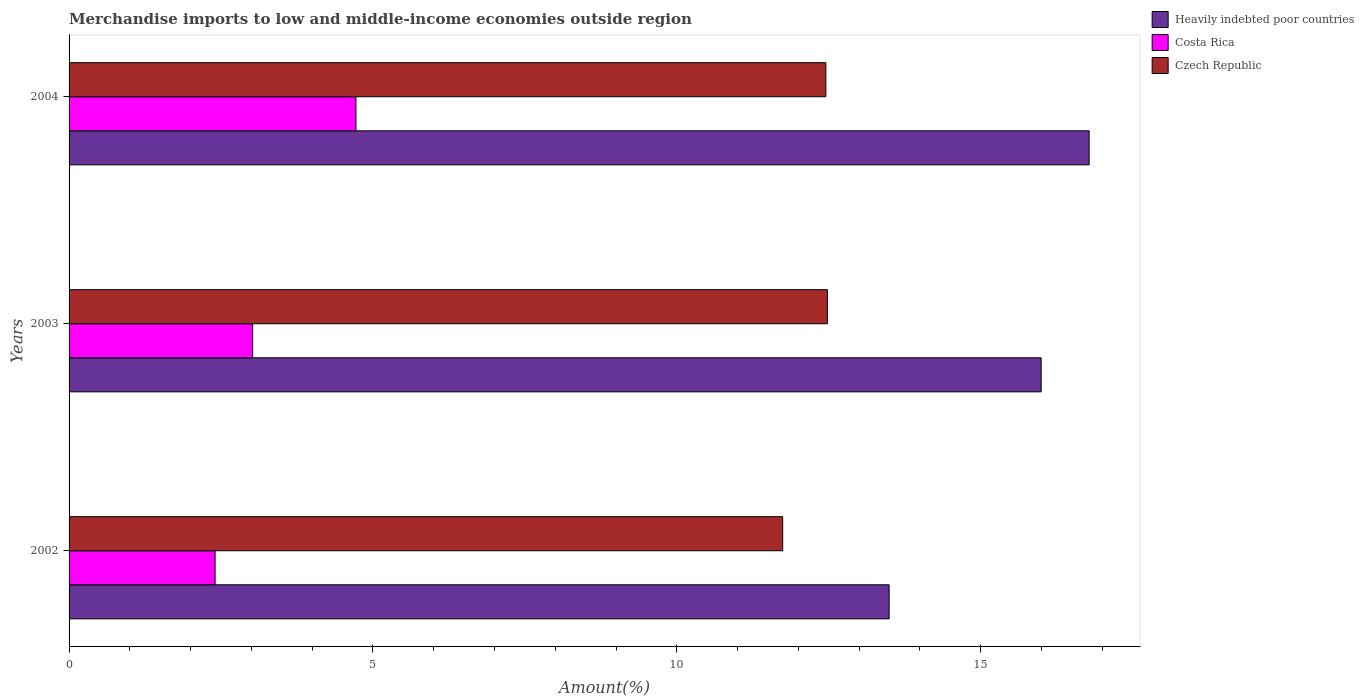In how many cases, is the number of bars for a given year not equal to the number of legend labels?
Keep it short and to the point. 0. What is the percentage of amount earned from merchandise imports in Czech Republic in 2004?
Offer a very short reply. 12.45. Across all years, what is the maximum percentage of amount earned from merchandise imports in Costa Rica?
Make the answer very short. 4.72. Across all years, what is the minimum percentage of amount earned from merchandise imports in Costa Rica?
Provide a succinct answer. 2.4. What is the total percentage of amount earned from merchandise imports in Costa Rica in the graph?
Make the answer very short. 10.14. What is the difference between the percentage of amount earned from merchandise imports in Czech Republic in 2003 and that in 2004?
Provide a short and direct response. 0.03. What is the difference between the percentage of amount earned from merchandise imports in Heavily indebted poor countries in 2004 and the percentage of amount earned from merchandise imports in Costa Rica in 2002?
Offer a terse response. 14.38. What is the average percentage of amount earned from merchandise imports in Heavily indebted poor countries per year?
Offer a very short reply. 15.42. In the year 2003, what is the difference between the percentage of amount earned from merchandise imports in Heavily indebted poor countries and percentage of amount earned from merchandise imports in Czech Republic?
Your answer should be compact. 3.52. What is the ratio of the percentage of amount earned from merchandise imports in Heavily indebted poor countries in 2003 to that in 2004?
Your answer should be very brief. 0.95. Is the percentage of amount earned from merchandise imports in Costa Rica in 2003 less than that in 2004?
Offer a terse response. Yes. What is the difference between the highest and the second highest percentage of amount earned from merchandise imports in Costa Rica?
Provide a succinct answer. 1.7. What is the difference between the highest and the lowest percentage of amount earned from merchandise imports in Heavily indebted poor countries?
Your response must be concise. 3.29. In how many years, is the percentage of amount earned from merchandise imports in Costa Rica greater than the average percentage of amount earned from merchandise imports in Costa Rica taken over all years?
Provide a succinct answer. 1. What does the 1st bar from the top in 2004 represents?
Your answer should be very brief. Czech Republic. What does the 1st bar from the bottom in 2002 represents?
Make the answer very short. Heavily indebted poor countries. What is the difference between two consecutive major ticks on the X-axis?
Offer a terse response. 5. Does the graph contain grids?
Make the answer very short. No. How many legend labels are there?
Keep it short and to the point. 3. How are the legend labels stacked?
Ensure brevity in your answer.  Vertical. What is the title of the graph?
Give a very brief answer. Merchandise imports to low and middle-income economies outside region. Does "Tanzania" appear as one of the legend labels in the graph?
Make the answer very short. No. What is the label or title of the X-axis?
Provide a succinct answer. Amount(%). What is the Amount(%) of Heavily indebted poor countries in 2002?
Offer a terse response. 13.49. What is the Amount(%) in Costa Rica in 2002?
Make the answer very short. 2.4. What is the Amount(%) in Czech Republic in 2002?
Make the answer very short. 11.74. What is the Amount(%) in Heavily indebted poor countries in 2003?
Ensure brevity in your answer.  15.99. What is the Amount(%) of Costa Rica in 2003?
Your answer should be compact. 3.02. What is the Amount(%) of Czech Republic in 2003?
Keep it short and to the point. 12.48. What is the Amount(%) in Heavily indebted poor countries in 2004?
Ensure brevity in your answer.  16.78. What is the Amount(%) in Costa Rica in 2004?
Your answer should be very brief. 4.72. What is the Amount(%) in Czech Republic in 2004?
Ensure brevity in your answer.  12.45. Across all years, what is the maximum Amount(%) of Heavily indebted poor countries?
Provide a succinct answer. 16.78. Across all years, what is the maximum Amount(%) in Costa Rica?
Your response must be concise. 4.72. Across all years, what is the maximum Amount(%) of Czech Republic?
Ensure brevity in your answer.  12.48. Across all years, what is the minimum Amount(%) of Heavily indebted poor countries?
Your answer should be very brief. 13.49. Across all years, what is the minimum Amount(%) of Costa Rica?
Your response must be concise. 2.4. Across all years, what is the minimum Amount(%) of Czech Republic?
Your response must be concise. 11.74. What is the total Amount(%) in Heavily indebted poor countries in the graph?
Offer a terse response. 46.27. What is the total Amount(%) in Costa Rica in the graph?
Give a very brief answer. 10.14. What is the total Amount(%) in Czech Republic in the graph?
Ensure brevity in your answer.  36.67. What is the difference between the Amount(%) of Heavily indebted poor countries in 2002 and that in 2003?
Your response must be concise. -2.5. What is the difference between the Amount(%) of Costa Rica in 2002 and that in 2003?
Your response must be concise. -0.62. What is the difference between the Amount(%) of Czech Republic in 2002 and that in 2003?
Keep it short and to the point. -0.74. What is the difference between the Amount(%) of Heavily indebted poor countries in 2002 and that in 2004?
Provide a succinct answer. -3.29. What is the difference between the Amount(%) in Costa Rica in 2002 and that in 2004?
Your answer should be very brief. -2.32. What is the difference between the Amount(%) of Czech Republic in 2002 and that in 2004?
Provide a short and direct response. -0.71. What is the difference between the Amount(%) in Heavily indebted poor countries in 2003 and that in 2004?
Your response must be concise. -0.79. What is the difference between the Amount(%) of Costa Rica in 2003 and that in 2004?
Offer a terse response. -1.7. What is the difference between the Amount(%) of Czech Republic in 2003 and that in 2004?
Keep it short and to the point. 0.03. What is the difference between the Amount(%) of Heavily indebted poor countries in 2002 and the Amount(%) of Costa Rica in 2003?
Your response must be concise. 10.47. What is the difference between the Amount(%) of Heavily indebted poor countries in 2002 and the Amount(%) of Czech Republic in 2003?
Make the answer very short. 1.02. What is the difference between the Amount(%) in Costa Rica in 2002 and the Amount(%) in Czech Republic in 2003?
Provide a succinct answer. -10.07. What is the difference between the Amount(%) of Heavily indebted poor countries in 2002 and the Amount(%) of Costa Rica in 2004?
Ensure brevity in your answer.  8.77. What is the difference between the Amount(%) in Heavily indebted poor countries in 2002 and the Amount(%) in Czech Republic in 2004?
Make the answer very short. 1.04. What is the difference between the Amount(%) in Costa Rica in 2002 and the Amount(%) in Czech Republic in 2004?
Your response must be concise. -10.05. What is the difference between the Amount(%) in Heavily indebted poor countries in 2003 and the Amount(%) in Costa Rica in 2004?
Give a very brief answer. 11.27. What is the difference between the Amount(%) of Heavily indebted poor countries in 2003 and the Amount(%) of Czech Republic in 2004?
Offer a terse response. 3.54. What is the difference between the Amount(%) of Costa Rica in 2003 and the Amount(%) of Czech Republic in 2004?
Keep it short and to the point. -9.43. What is the average Amount(%) in Heavily indebted poor countries per year?
Offer a terse response. 15.42. What is the average Amount(%) in Costa Rica per year?
Your answer should be very brief. 3.38. What is the average Amount(%) in Czech Republic per year?
Your response must be concise. 12.22. In the year 2002, what is the difference between the Amount(%) in Heavily indebted poor countries and Amount(%) in Costa Rica?
Offer a very short reply. 11.09. In the year 2002, what is the difference between the Amount(%) of Heavily indebted poor countries and Amount(%) of Czech Republic?
Make the answer very short. 1.75. In the year 2002, what is the difference between the Amount(%) of Costa Rica and Amount(%) of Czech Republic?
Keep it short and to the point. -9.34. In the year 2003, what is the difference between the Amount(%) of Heavily indebted poor countries and Amount(%) of Costa Rica?
Make the answer very short. 12.97. In the year 2003, what is the difference between the Amount(%) of Heavily indebted poor countries and Amount(%) of Czech Republic?
Your answer should be very brief. 3.52. In the year 2003, what is the difference between the Amount(%) in Costa Rica and Amount(%) in Czech Republic?
Your answer should be compact. -9.46. In the year 2004, what is the difference between the Amount(%) of Heavily indebted poor countries and Amount(%) of Costa Rica?
Keep it short and to the point. 12.06. In the year 2004, what is the difference between the Amount(%) of Heavily indebted poor countries and Amount(%) of Czech Republic?
Provide a succinct answer. 4.33. In the year 2004, what is the difference between the Amount(%) in Costa Rica and Amount(%) in Czech Republic?
Provide a short and direct response. -7.73. What is the ratio of the Amount(%) in Heavily indebted poor countries in 2002 to that in 2003?
Make the answer very short. 0.84. What is the ratio of the Amount(%) of Costa Rica in 2002 to that in 2003?
Your answer should be very brief. 0.8. What is the ratio of the Amount(%) in Czech Republic in 2002 to that in 2003?
Keep it short and to the point. 0.94. What is the ratio of the Amount(%) in Heavily indebted poor countries in 2002 to that in 2004?
Your answer should be very brief. 0.8. What is the ratio of the Amount(%) of Costa Rica in 2002 to that in 2004?
Your answer should be very brief. 0.51. What is the ratio of the Amount(%) in Czech Republic in 2002 to that in 2004?
Provide a succinct answer. 0.94. What is the ratio of the Amount(%) in Heavily indebted poor countries in 2003 to that in 2004?
Your response must be concise. 0.95. What is the ratio of the Amount(%) in Costa Rica in 2003 to that in 2004?
Offer a terse response. 0.64. What is the ratio of the Amount(%) in Czech Republic in 2003 to that in 2004?
Provide a succinct answer. 1. What is the difference between the highest and the second highest Amount(%) of Heavily indebted poor countries?
Your answer should be very brief. 0.79. What is the difference between the highest and the second highest Amount(%) of Costa Rica?
Provide a short and direct response. 1.7. What is the difference between the highest and the second highest Amount(%) in Czech Republic?
Offer a terse response. 0.03. What is the difference between the highest and the lowest Amount(%) in Heavily indebted poor countries?
Your response must be concise. 3.29. What is the difference between the highest and the lowest Amount(%) in Costa Rica?
Provide a short and direct response. 2.32. What is the difference between the highest and the lowest Amount(%) of Czech Republic?
Give a very brief answer. 0.74. 